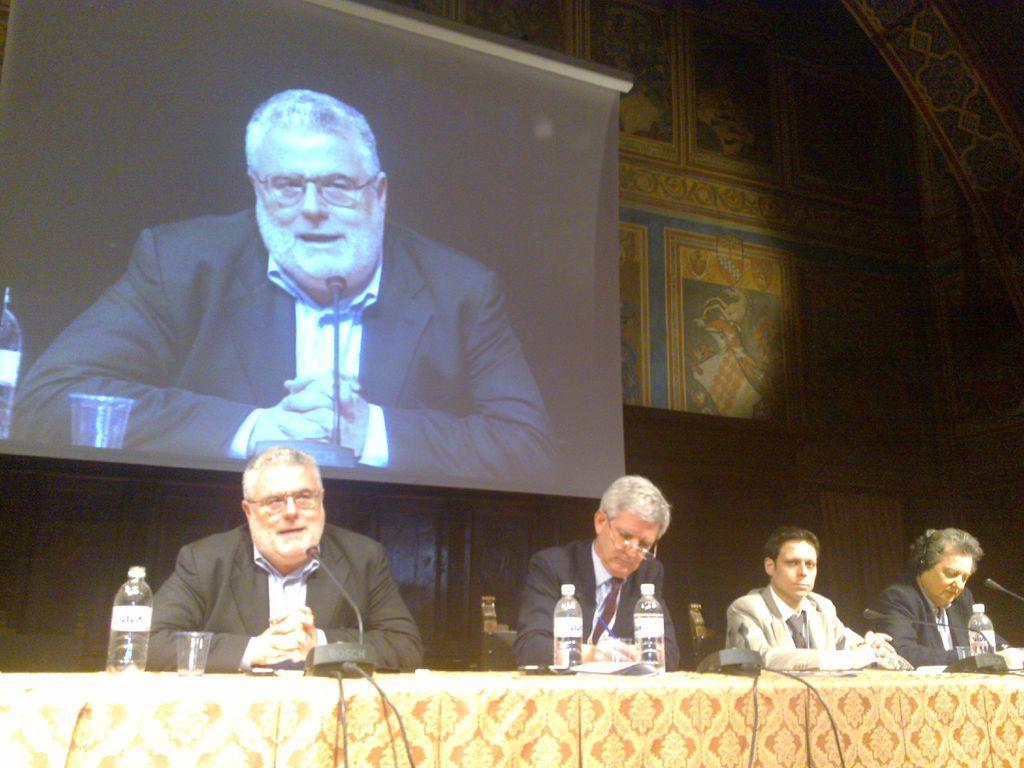Could you give a brief overview of what you see in this image? In this image we can see there are a few people sitting on a chair, in front of the person there is a table. On the table there are water bottles, glass, papers, mic and some cables. In the background there is a screen attached to the wall. On the screen we can see the person. 